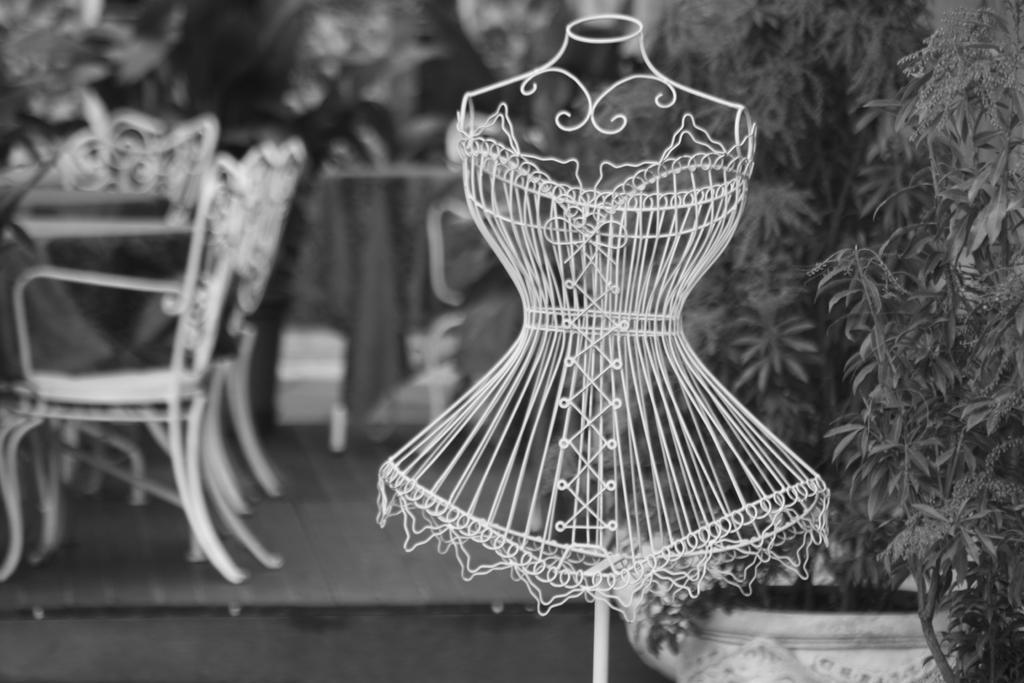Can you describe this image briefly? In the image we can see there is a dress shaped iron structure kept on the pole and there are chairs kept on the ground. There are trees and the image is little blurry at the back. The image is in black and white colour. 